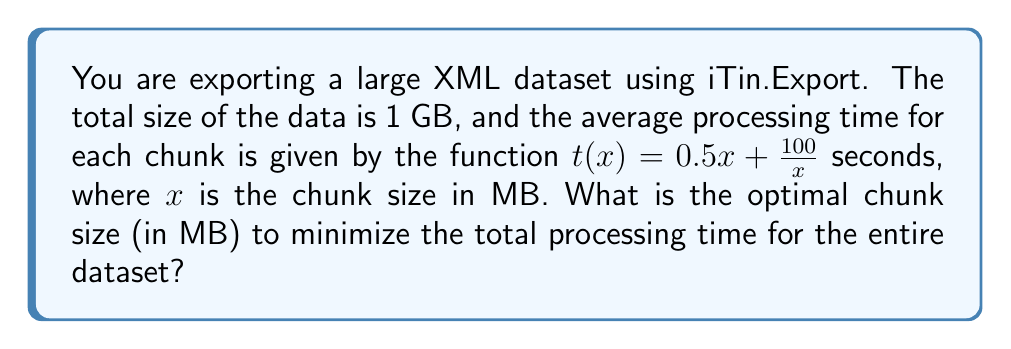Help me with this question. To solve this problem, we'll follow these steps:

1) First, we need to express the total processing time as a function of chunk size. Let's call this function $T(x)$.

2) The number of chunks will be $\frac{1000}{x}$ (since the total size is 1 GB = 1000 MB).

3) The total processing time will be the number of chunks multiplied by the time per chunk:

   $$T(x) = \frac{1000}{x} \cdot (0.5x + \frac{100}{x}) = 500 + \frac{100000}{x^2}$$

4) To find the minimum of this function, we need to find where its derivative equals zero:

   $$T'(x) = 0 - \frac{200000}{x^3} = 0$$

5) Solving this equation:

   $$-\frac{200000}{x^3} = 0$$
   $$x^3 = 200000$$
   $$x = \sqrt[3]{200000} \approx 58.48$$

6) To confirm this is a minimum, we can check the second derivative is positive:

   $$T''(x) = \frac{600000}{x^4}$$

   Which is indeed positive for all positive $x$.

7) Therefore, the optimal chunk size is approximately 58.48 MB.
Answer: 58.48 MB 